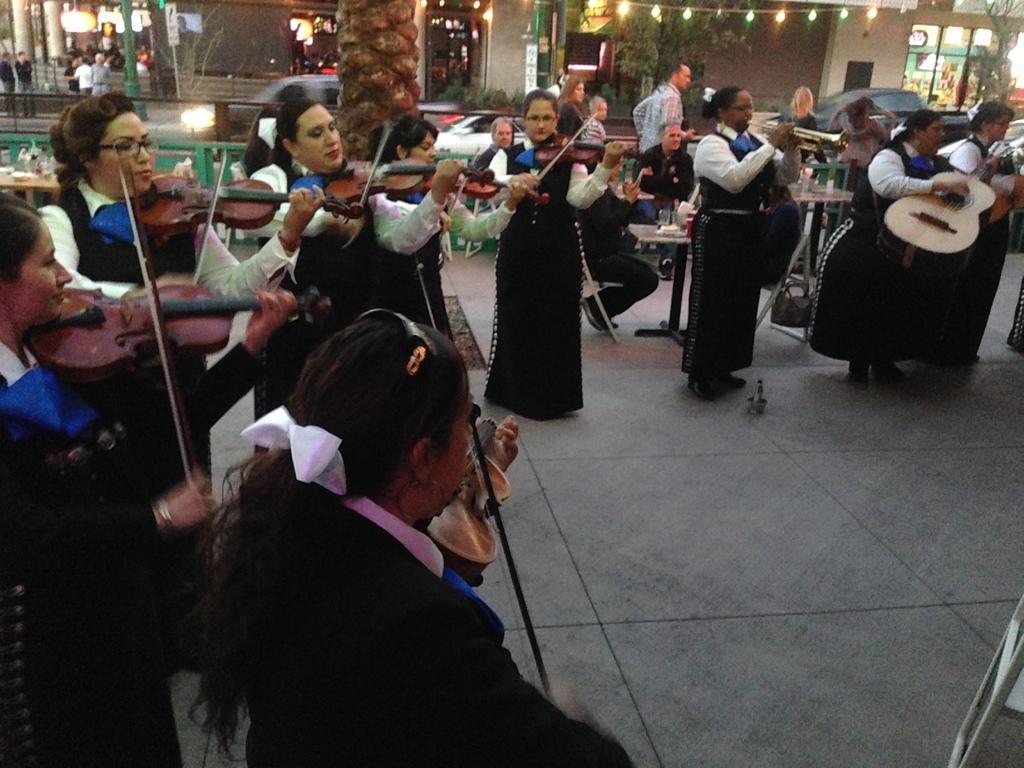Can you describe this image briefly? In the image there are several women playing violin and trumpet. They all wore same kind of dress and in the back of those women there are men sitting around the table. It seem to be a restaurant and the whole image seems to be in a mall. There are tree and stores in the background with some lights 